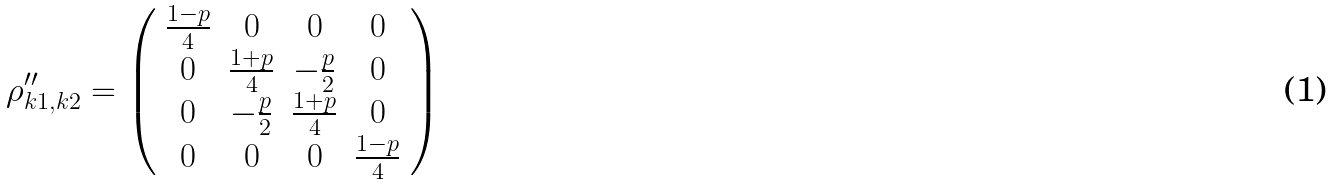Convert formula to latex. <formula><loc_0><loc_0><loc_500><loc_500>\rho _ { k 1 , k 2 } ^ { \prime \prime } = \left ( \begin{array} { c c c c } \frac { 1 - p } { 4 } & 0 & 0 & 0 \\ 0 & \frac { 1 + p } { 4 } & - \frac { p } { 2 } & 0 \\ 0 & - \frac { p } { 2 } & \frac { 1 + p } { 4 } & 0 \\ 0 & 0 & 0 & \frac { 1 - p } { 4 } \end{array} \right )</formula> 